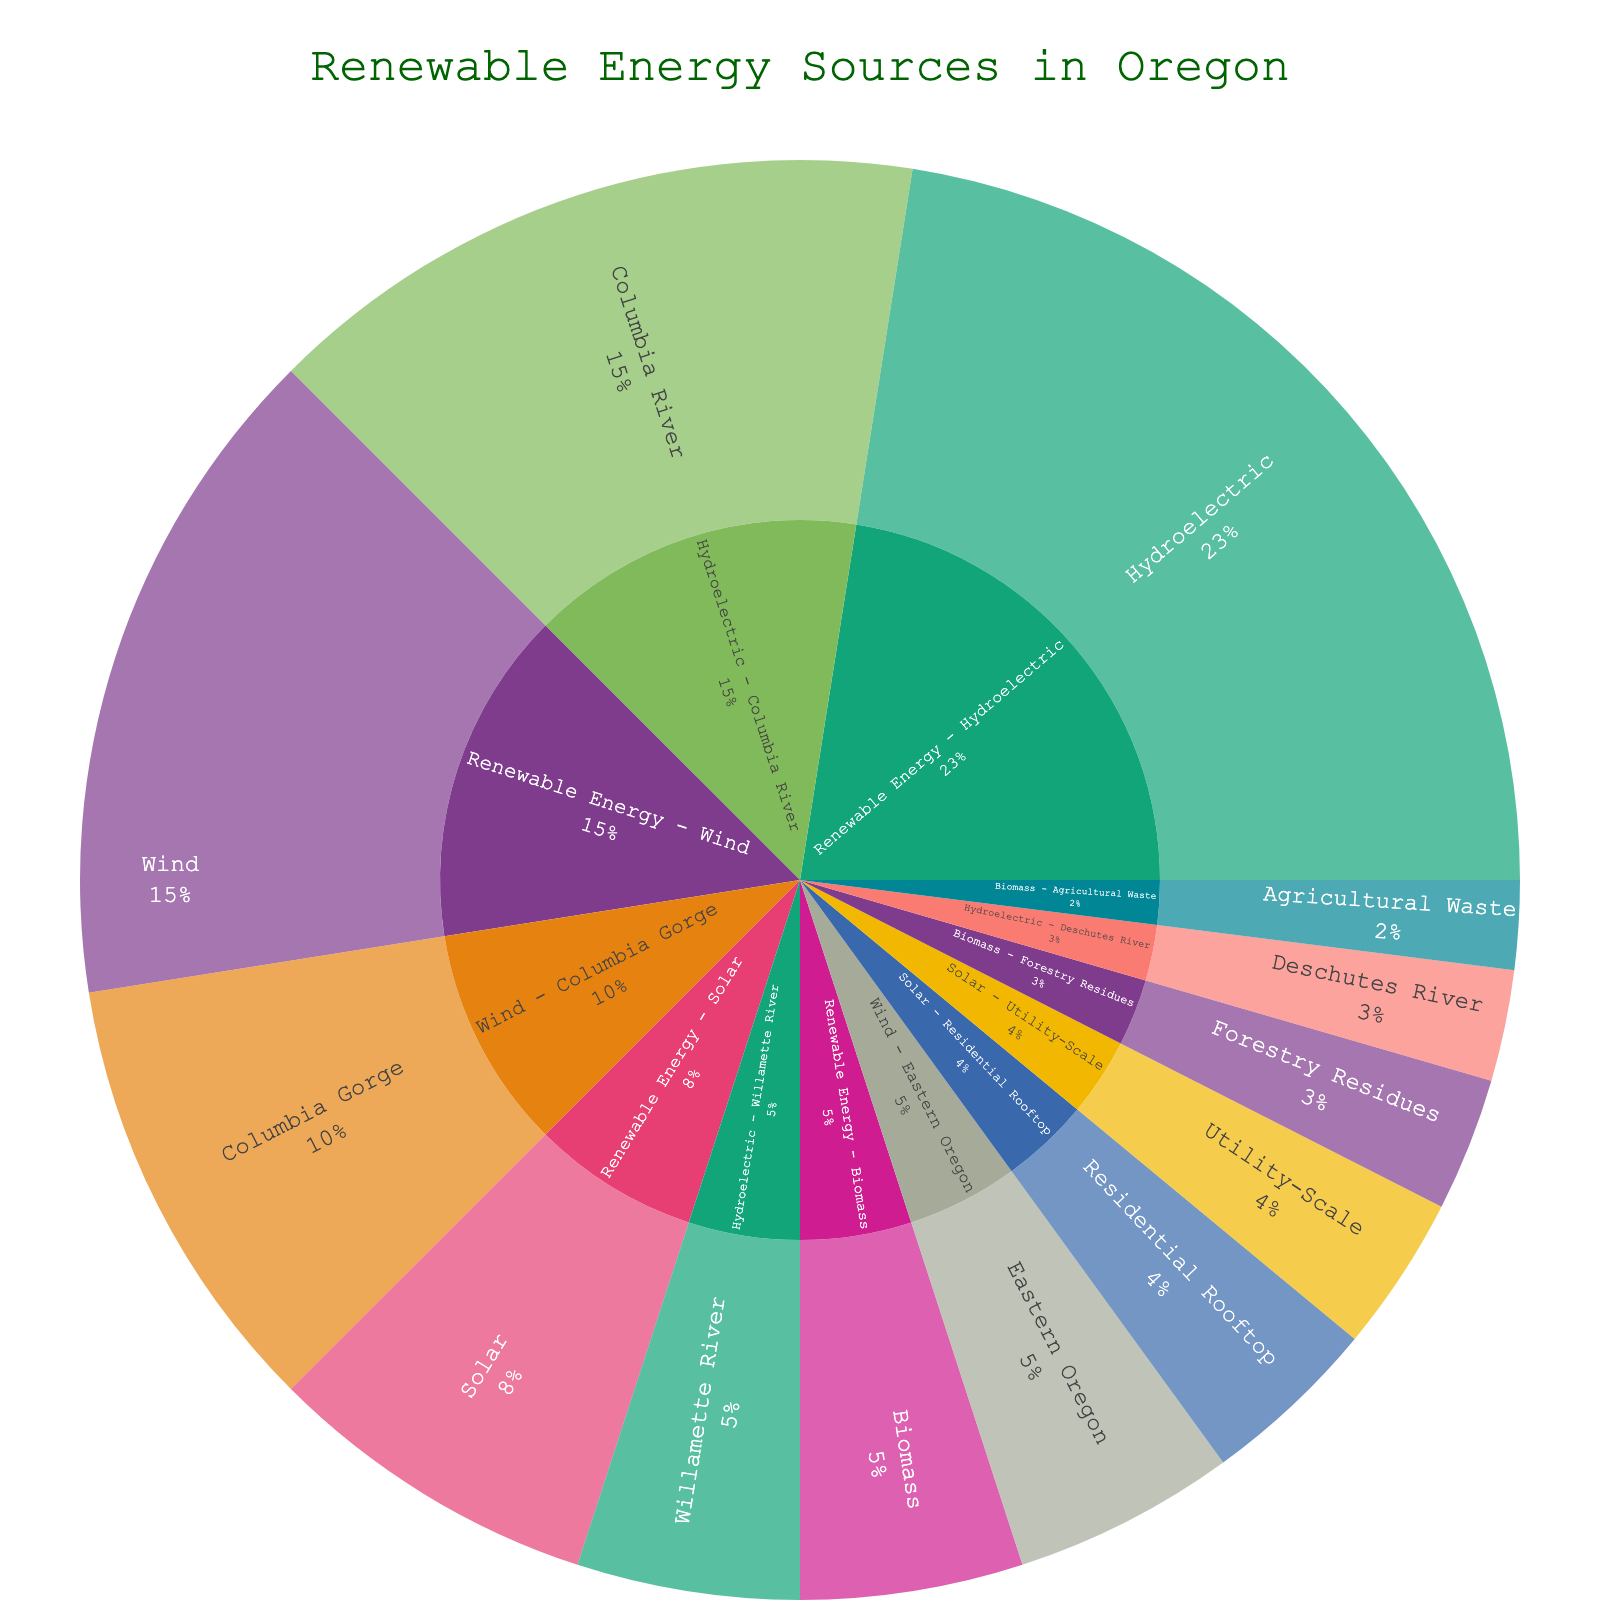What does the sunburst plot represent? The plot shows the breakdown of renewable energy sources in Oregon, including solar, wind, hydroelectric, and biomass, with subcategories for each type.
Answer: Breakdown of renewable energy sources in Oregon Which renewable energy source has the largest share? The hydroelectric category has the largest portion of the sunburst plot based on visual inspection of the segment sizes.
Answer: Hydroelectric How much energy, in percentage, comes from wind compared to the total renewable energy? Wind energy represents its segment of the plot, which is 30 out of the total 100 (15 + 30 + 45 + 10), which equals 30%.
Answer: 30% What are the subcategories within solar energy? The sunburst plot shows two segments within solar energy: Residential Rooftop and Utility-Scale.
Answer: Residential Rooftop and Utility-Scale Which subcategory of wind energy contributes the most? Within the wind energy category, the Columbia Gorge segment is larger, representing a higher value compared to Eastern Oregon.
Answer: Columbia Gorge Out of the renewable energy sources, which has the smallest overall contribution and what subcategories make it up? Biomass has the smallest segment among the four main categories. It consists of Forestry Residues and Agricultural Waste subcategories.
Answer: Biomass: Forestry Residues, Agricultural Waste How does the contribution of the Columbia River to hydroelectric energy compare to the total hydroelectric contribution? The Columbia River segment is 30, and the total hydroelectric category sums up to 45 (30 + 10 + 5), making the Columbia River contribute approximately 67% of hydroelectric energy.
Answer: 67% If you add up the contributions of Residential Rooftop and Utility-Scale solar energy, what percentage of the total renewable energy does it cover? Add 8 (Residential Rooftop) + 7 (Utility-Scale) for a total of 15. This is 15% of the total renewable energy (100).
Answer: 15% Which subcategory has a higher value: Willamette River hydroelectric or Eastern Oregon wind? The Willamette River hydroelectric segment has a value of 10, which is equal to the Eastern Oregon wind segment, both contributing the same.
Answer: Equal (10 each) What combined value do the biomass subcategories contribute, and how does it compare to the value of wind energy? Forestry Residues contribute 6, and Agricultural Waste contributes 4, totaling 10 for biomass, which is one-third of the wind energy value (30).
Answer: Biomass: 10, Wind: 30 